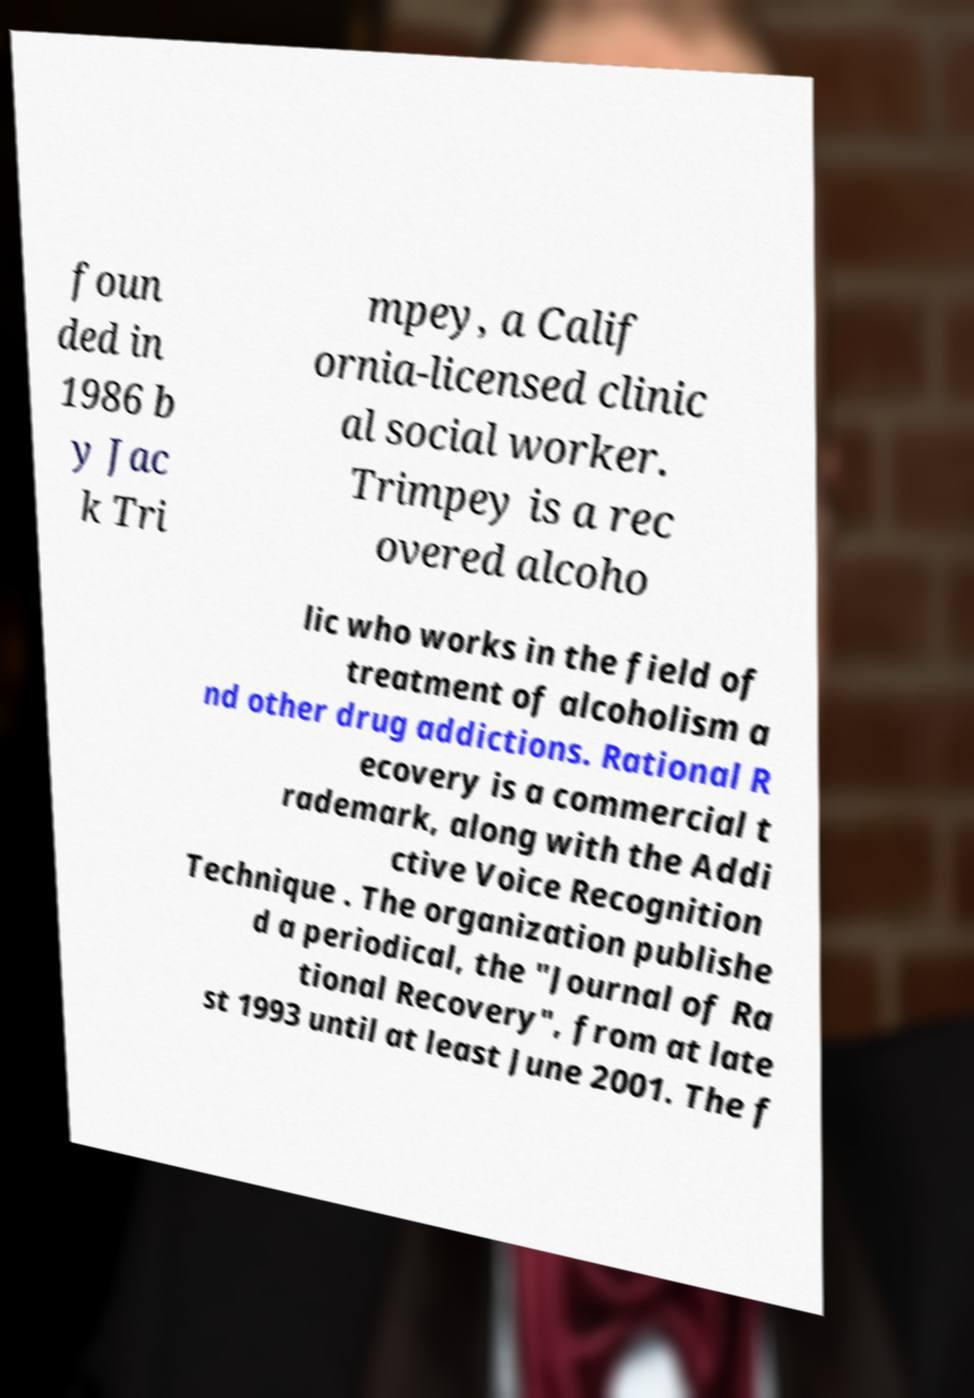Could you assist in decoding the text presented in this image and type it out clearly? foun ded in 1986 b y Jac k Tri mpey, a Calif ornia-licensed clinic al social worker. Trimpey is a rec overed alcoho lic who works in the field of treatment of alcoholism a nd other drug addictions. Rational R ecovery is a commercial t rademark, along with the Addi ctive Voice Recognition Technique . The organization publishe d a periodical, the "Journal of Ra tional Recovery", from at late st 1993 until at least June 2001. The f 